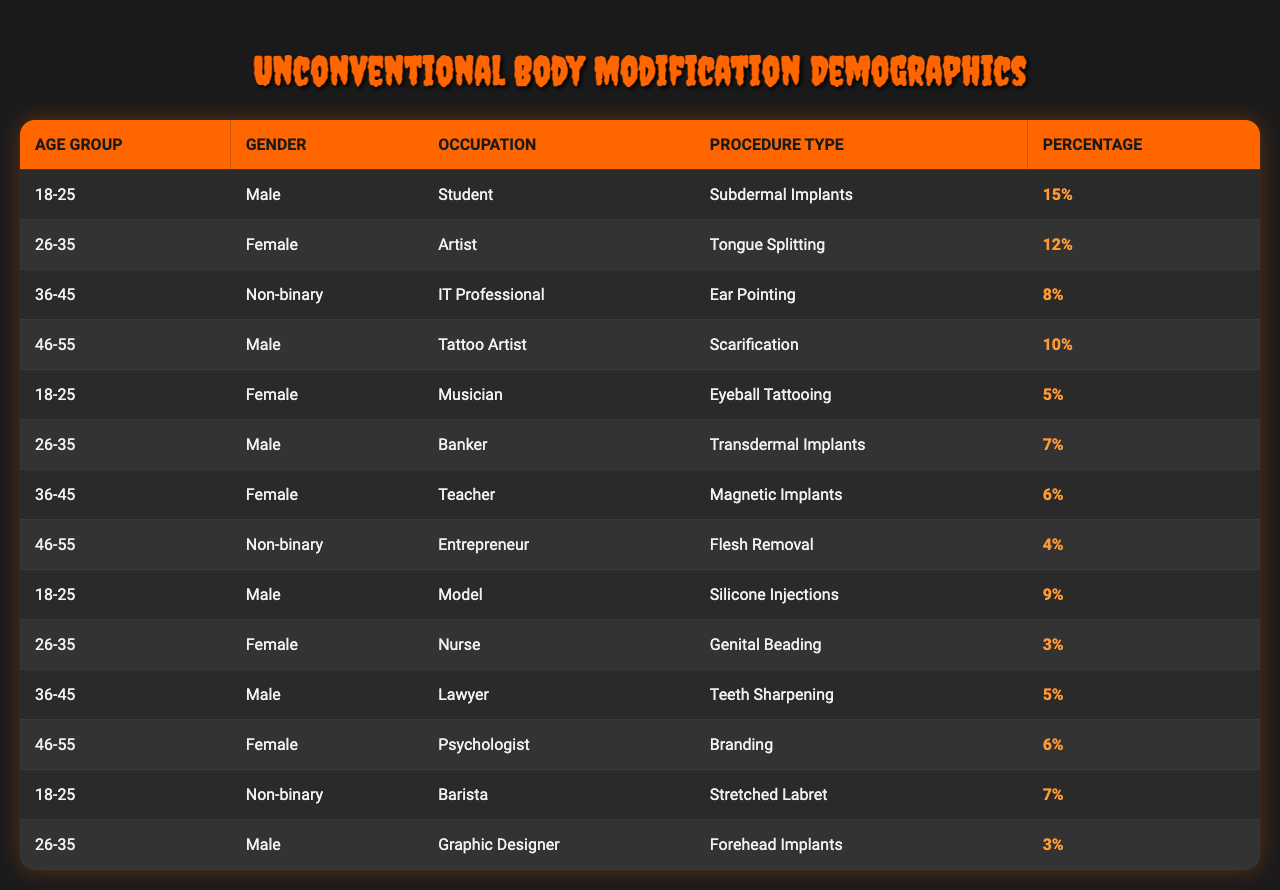What percentage of clients aged 18-25 are interested in tongue splitting? The table lists the percentage for tongue splitting under the age group 18-25, which is not mentioned in that demographic. Therefore, the answer is 0%.
Answer: 0% What is the most popular procedure type among non-binary clients? The table shows that the most popular procedure among non-binary clients is "Subdermal Implants," with a percentage of 15%.
Answer: 15% How many different occupations are represented for the age group 26-35? In the table, there are three different occupations listed for the age group 26-35: Artist, Banker, and Nurse.
Answer: 3 Which gender has the highest percentage of clients interested in branding? Looking at the table, only females are listed for branding, and they account for 6%. Therefore, the answer is female.
Answer: Female What is the average percentage of procedures for clients aged 36-45? We calculate the average by adding the percentages for each procedure in that age group: 8%, 6%, and 5%. The sum is 19%, and there are three entries, thus the average is 19%/3 = 6.33%.
Answer: 6.33% Is there any procedure that has a percentage above 10% among clients aged 46-55? Checking the percentages for the 46-55 age group, the highest is 10% for "Scarification," but all other values are lower; hence the answer is false.
Answer: False Which age group has the highest representation for subdermal implants? The age group 18-25 has the highest percentage at 15% for subdermal implants, as it is the only entry in that row.
Answer: 18-25 If we add all percentages for the procedure type "Eyeball Tattooing," what do we get? The only entry for "Eyeball Tattooing" is under the 18-25 age group with a percentage of 5%, so the sum is just 5%.
Answer: 5% Are there any procedures listed that have less than 5% representation? Yes, according to the table, "Genital Beading," "Flesh Removal," and "Branding" are below 5%, with percentages of 3%, 4%, and 6%, respectively.
Answer: Yes What percentage of clients who are teachers and undergo modifications falls in the age group 36-45? The table shows that a female teacher in the 36-45 age group is seeking magnetic implants with a percentage of 6%.
Answer: 6% 